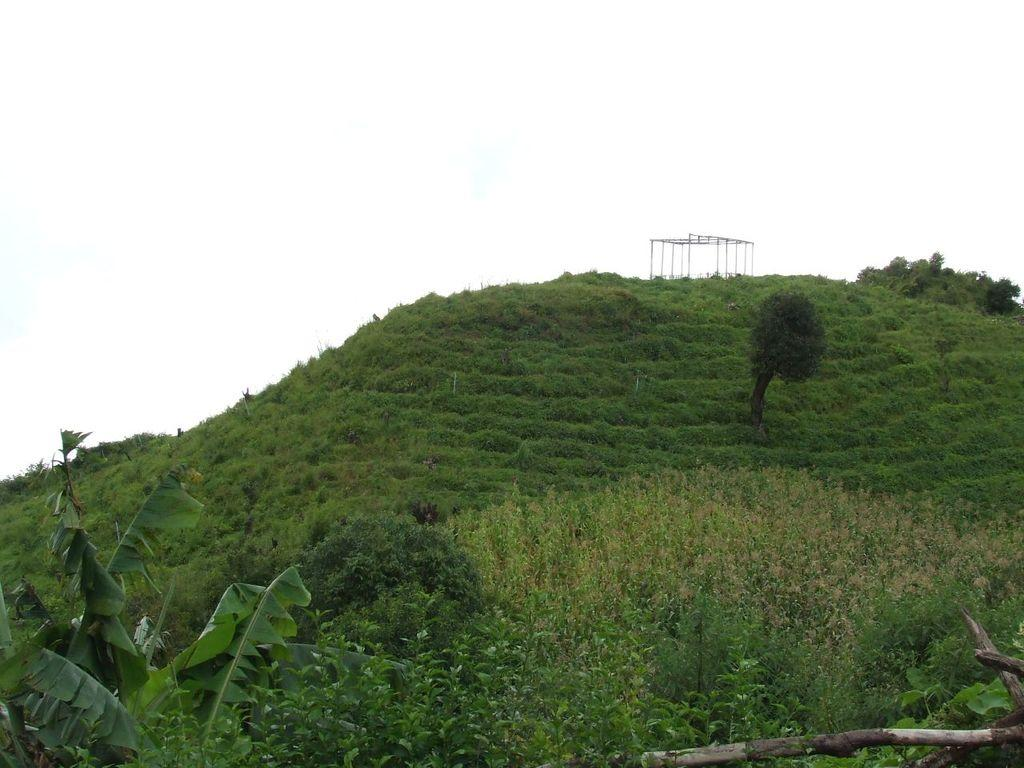Where was the image taken? The image is clicked outside. What can be seen in the foreground and middle of the image? There are trees at the bottom and middle of the image. What is visible at the top of the image? The sky is visible at the top of the image. What type of location is suggested by the image? The image appears to be taken in a hilly area. How long does it take for the truck to pass by in the image? There is no truck present in the image, so it is not possible to determine how long it would take for it to pass by. 